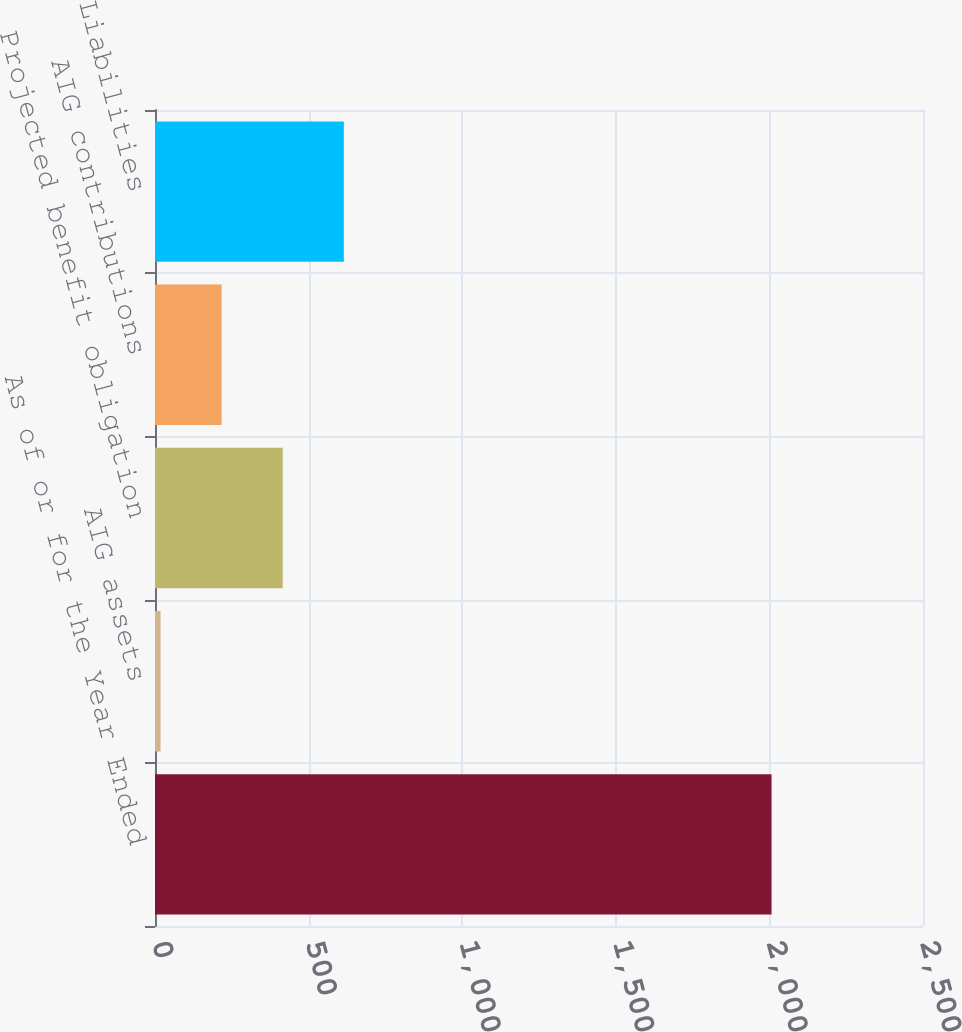<chart> <loc_0><loc_0><loc_500><loc_500><bar_chart><fcel>As of or for the Year Ended<fcel>AIG assets<fcel>Projected benefit obligation<fcel>AIG contributions<fcel>Liabilities<nl><fcel>2007<fcel>18<fcel>415.8<fcel>216.9<fcel>614.7<nl></chart> 